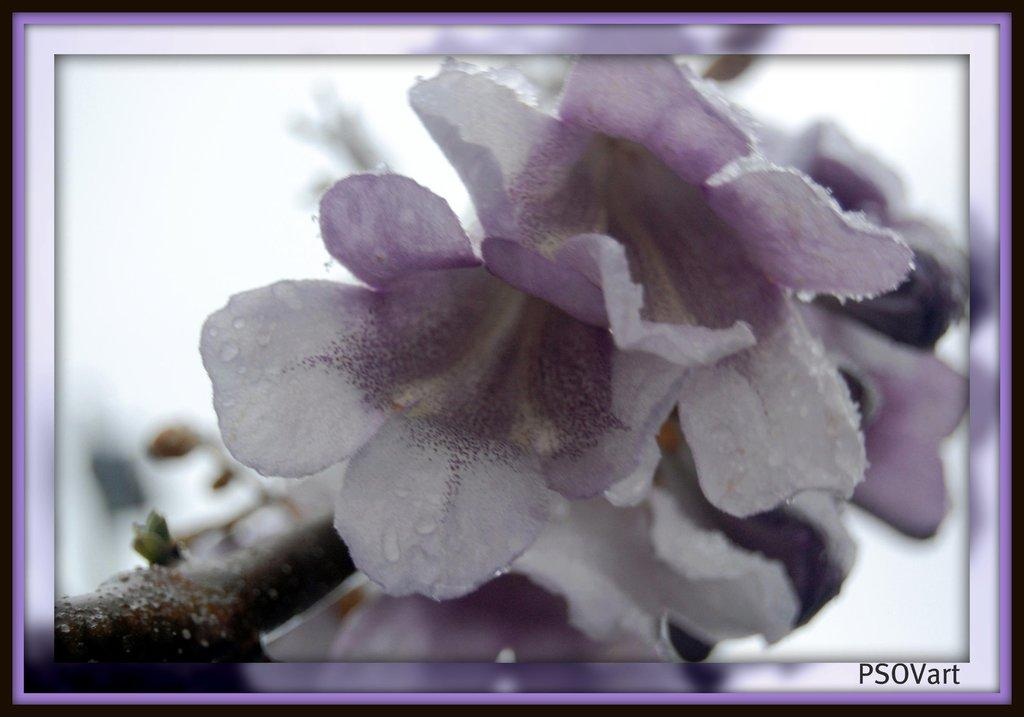What type of flowers can be seen on the plant in the image? There are white flowers on a plant in the image. What part of the natural environment is visible in the image? The sky is visible on the left side of the image. Is there any text or marking in the image? Yes, there is a watermark in the bottom right corner of the image. What type of suit is the plant wearing in the image? There is no suit present in the image, as it features a plant with white flowers and a watermark. 